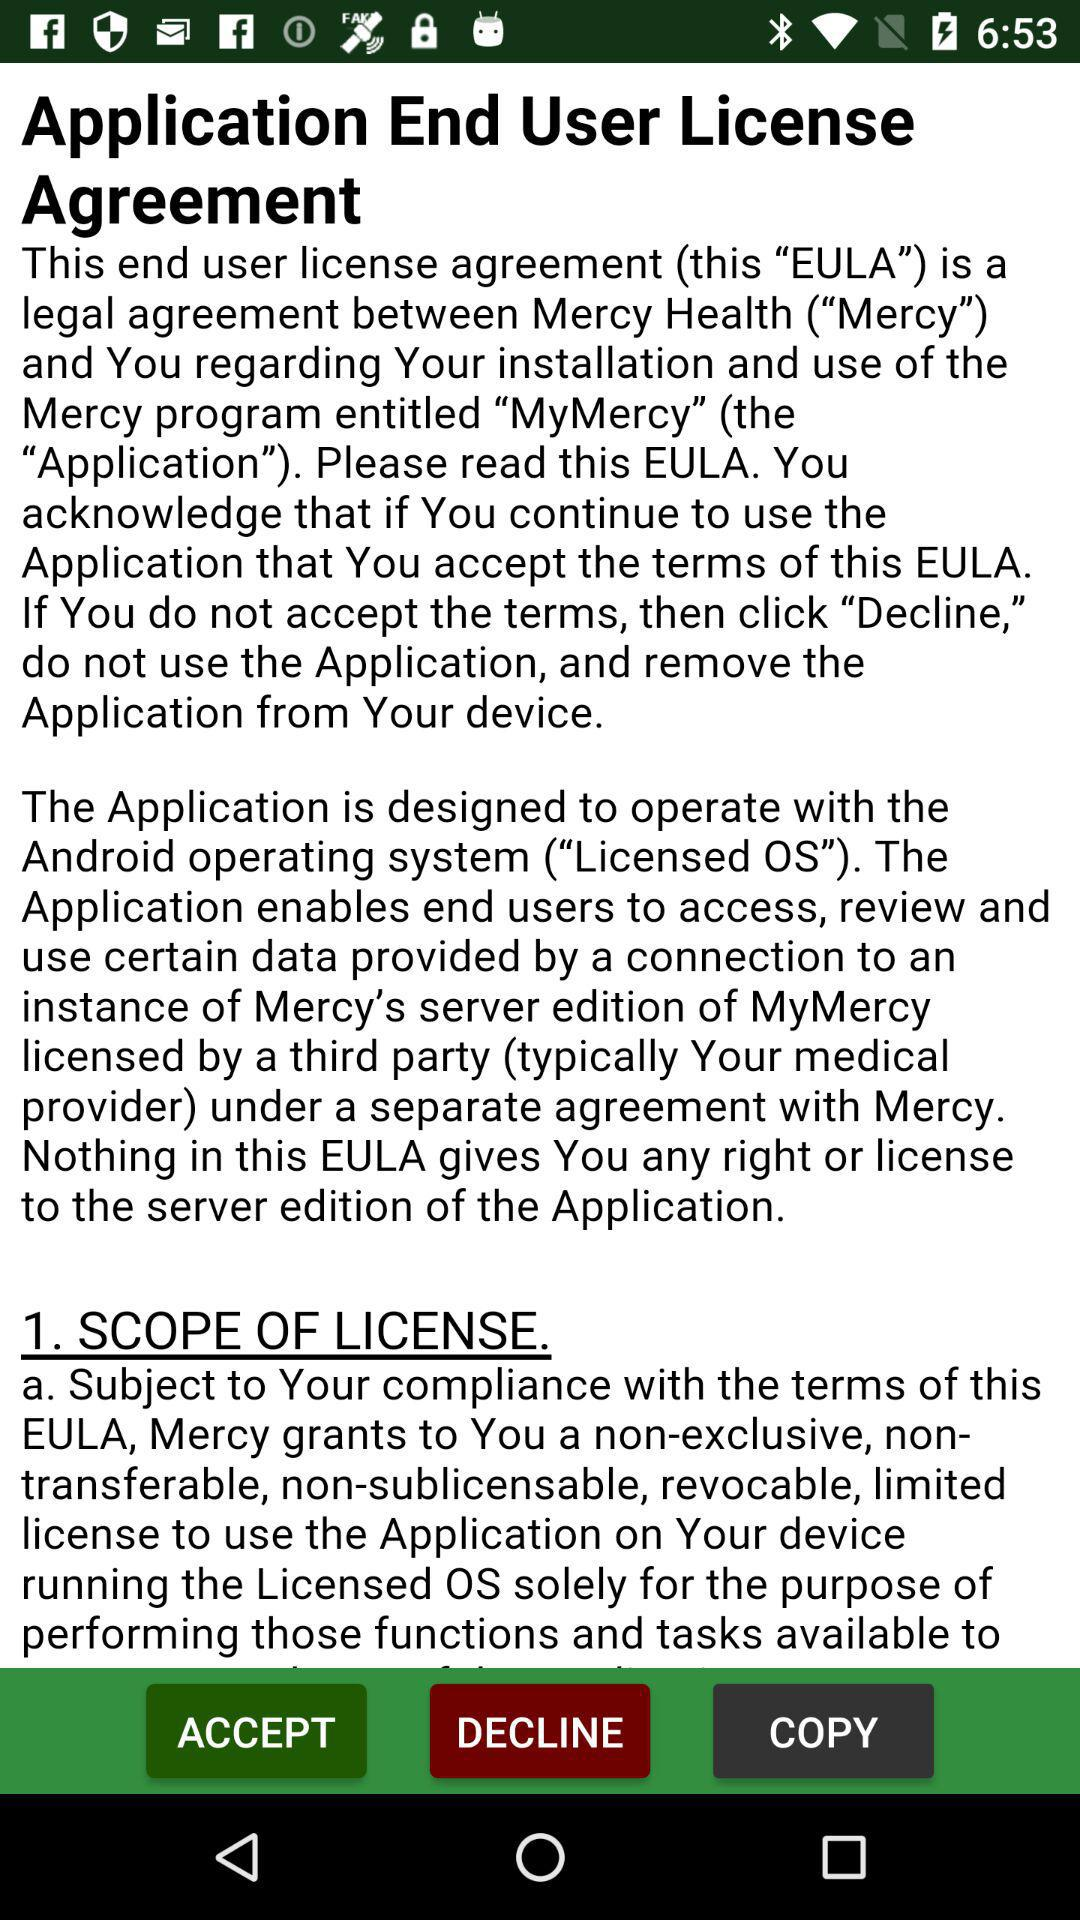What is the application name? The application name is "MyMercy". 